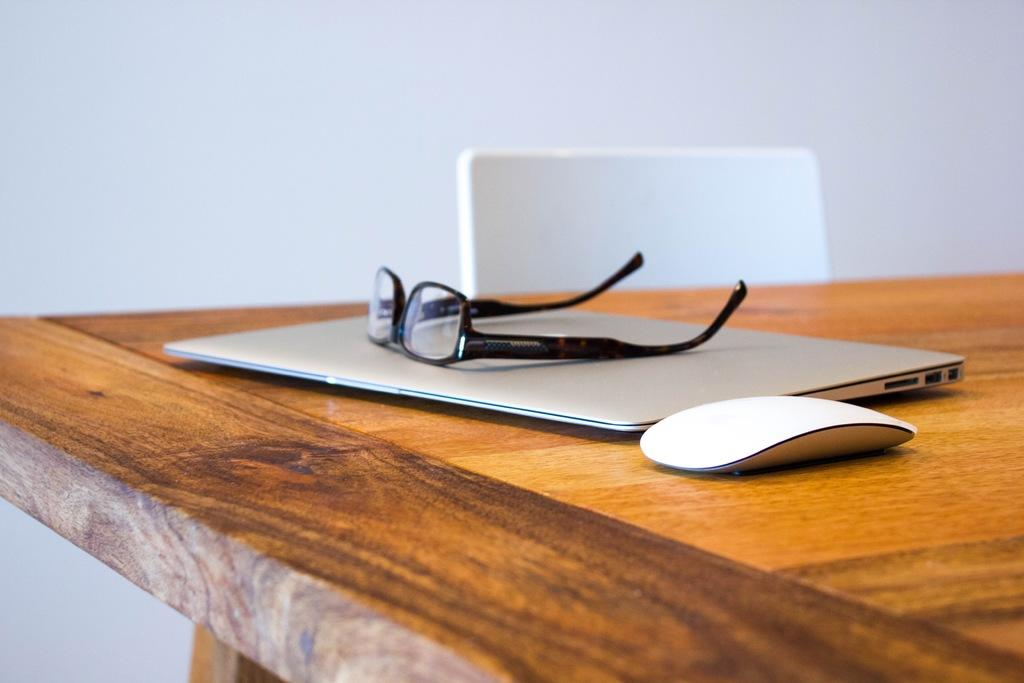What piece of furniture is present in the image? There is a table in the image. What object related to computer usage can be seen on the table? There is a laptop mouse on the table. What item for vision correction is on the table? There are spectacles on the table. What type of seating is located beside the table? There is a chair beside the table. What architectural feature is visible in the image? There is a wall visible in the image. What type of truck is parked next to the wall in the image? There is no truck present in the image; only a table, laptop mouse, spectacles, chair, and wall are visible. 